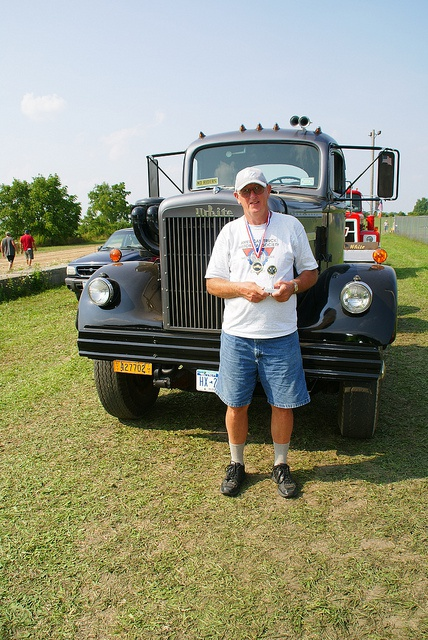Describe the objects in this image and their specific colors. I can see truck in lavender, black, gray, lightgray, and darkgray tones, people in lavender, white, darkgray, and blue tones, car in lavender, darkgray, black, lightgray, and gray tones, people in lavender, black, gray, darkgray, and maroon tones, and people in lavender, maroon, brown, and black tones in this image. 